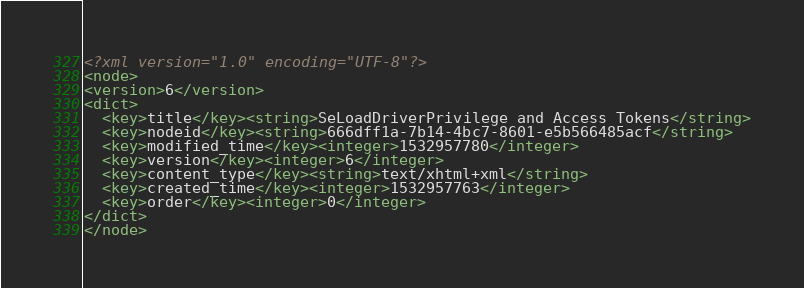<code> <loc_0><loc_0><loc_500><loc_500><_XML_><?xml version="1.0" encoding="UTF-8"?>
<node>
<version>6</version>
<dict>
  <key>title</key><string>SeLoadDriverPrivilege and Access Tokens</string>
  <key>nodeid</key><string>666dff1a-7b14-4bc7-8601-e5b566485acf</string>
  <key>modified_time</key><integer>1532957780</integer>
  <key>version</key><integer>6</integer>
  <key>content_type</key><string>text/xhtml+xml</string>
  <key>created_time</key><integer>1532957763</integer>
  <key>order</key><integer>0</integer>
</dict>
</node>
</code> 